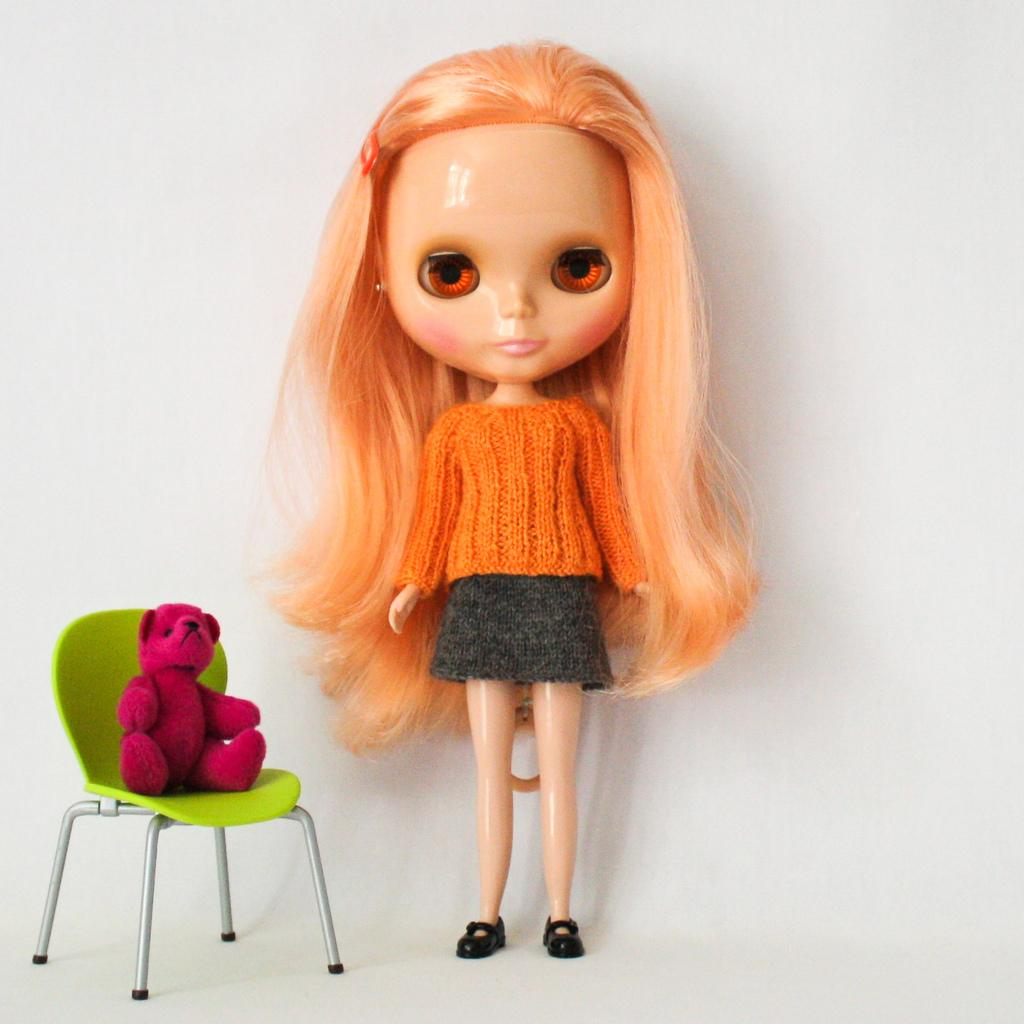What is present in the image? There is a doll in the image. Can you describe another object in the image? There is a teddy bear doll on a chair in the image. What type of honey can be seen dripping from the doll's hair in the image? There is no honey present in the image, nor is it dripping from the doll's hair. 